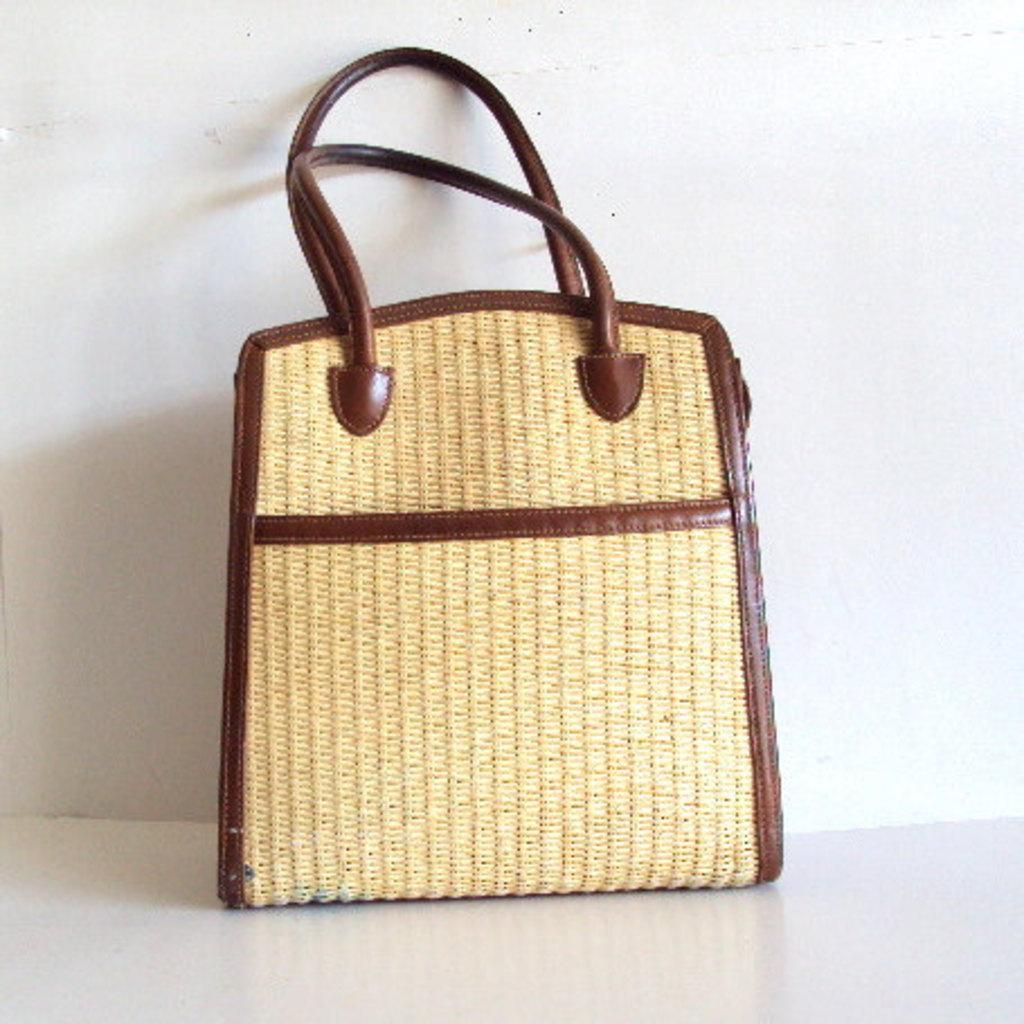What type of bag is visible in the image? There is a bag with straps in the image. What items are inside the bag? There are belts inside the bag. Where is the bag located in the image? The bag is placed on the floor. What can be seen in the background of the image? There is a wall visible in the background of the image. What type of bridge can be seen in the image? There is no bridge present in the image; it features a bag with straps, belts inside the bag, and a wall in the background. How many people are engaged in a discussion in the image? There is no discussion taking place in the image; it only shows a bag with straps, belts inside the bag, and a wall in the background. 